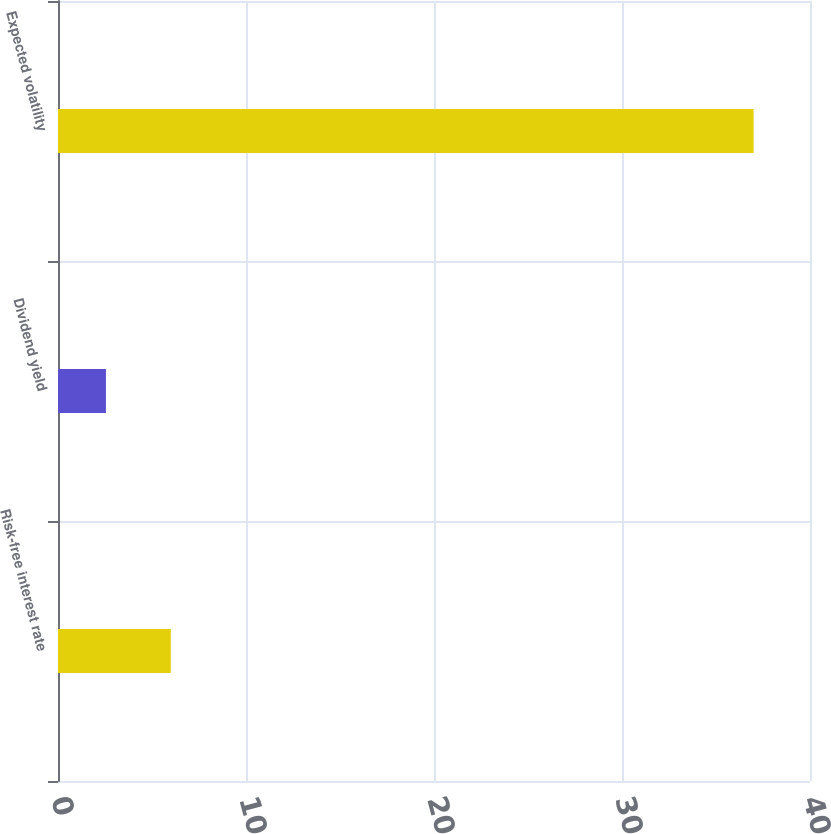Convert chart to OTSL. <chart><loc_0><loc_0><loc_500><loc_500><bar_chart><fcel>Risk-free interest rate<fcel>Dividend yield<fcel>Expected volatility<nl><fcel>6<fcel>2.55<fcel>37<nl></chart> 